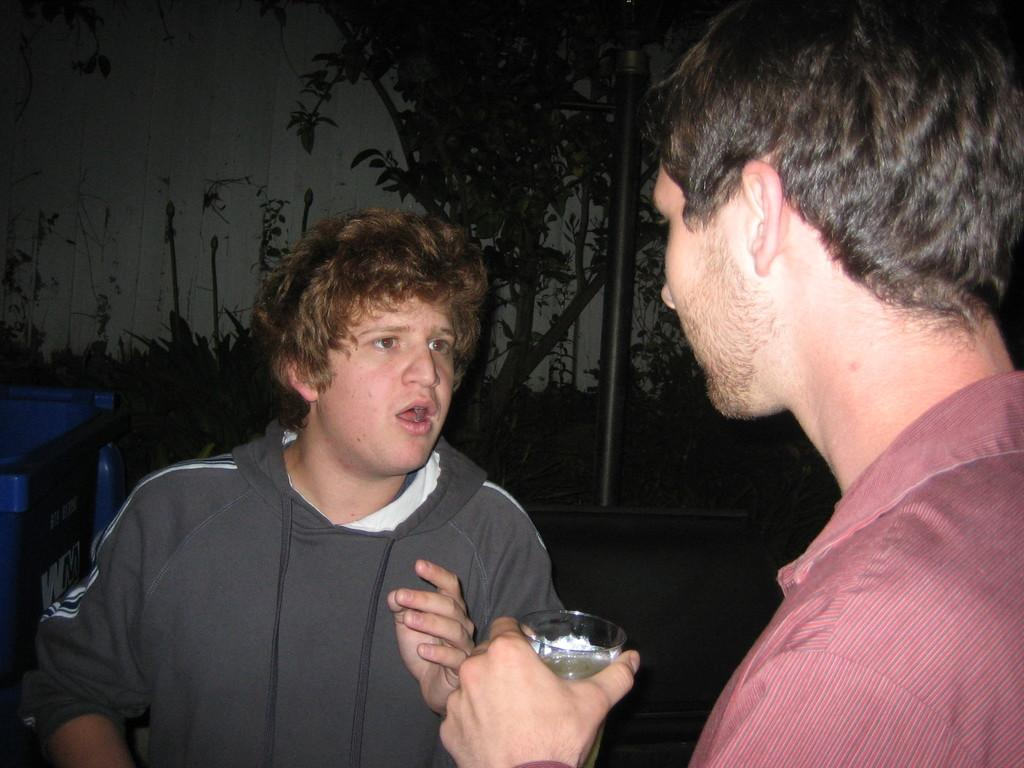How many people are in the image? There are two men in the image. What is one of the men holding in his hand? One of the men is holding a glass in his hand. What object can be used for waste disposal in the image? There is a bin in the image. What type of vegetation can be seen in the background of the image? There is a plant in the background of the image. What architectural feature is visible in the background of the image? There is a pole in the background of the image. What type of engine is visible in the image? There is no engine present in the image. Can you provide a suggestion for improving the plant's health in the image? There is no need to provide a suggestion for improving the plant's health, as the image does not show any issues with the plant. 